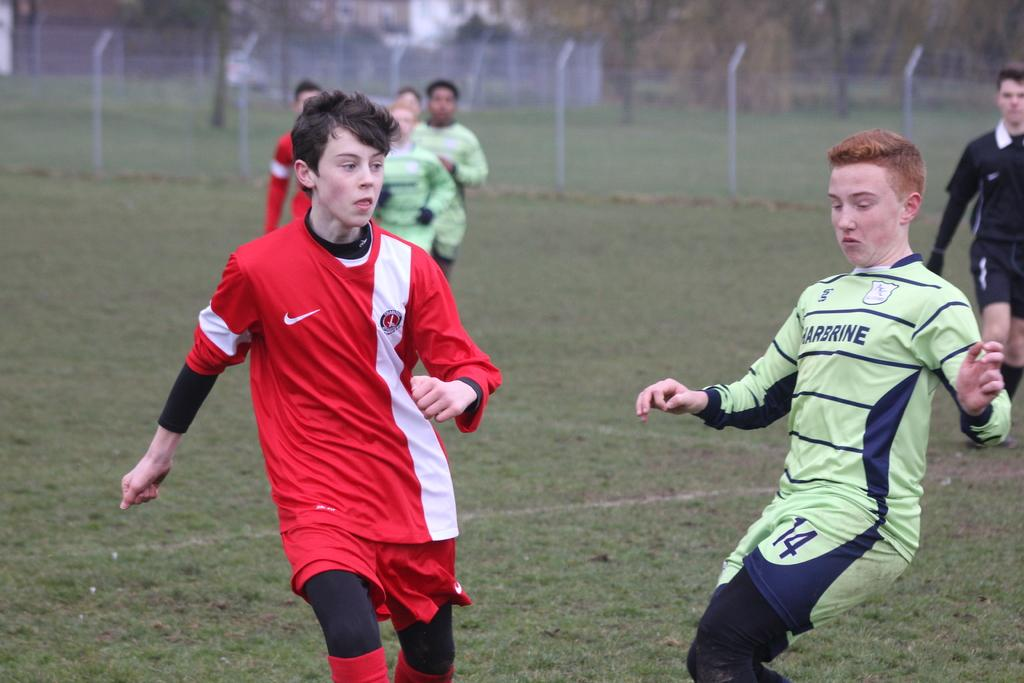<image>
Provide a brief description of the given image. Player number 14 is leaned back as though he's losing his balance. 